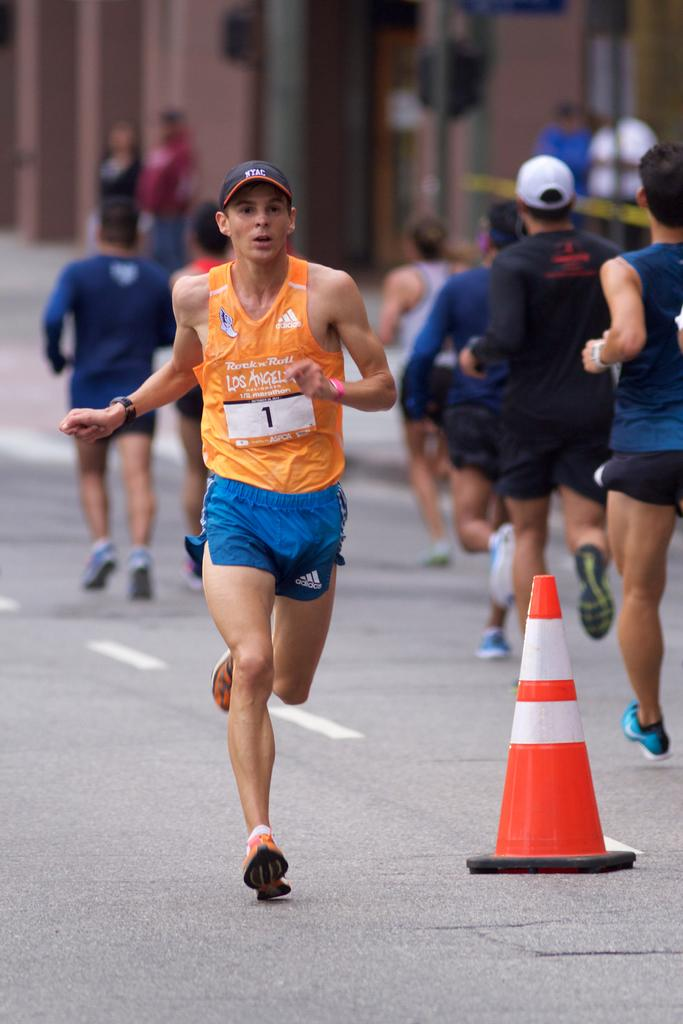What is happening in the image involving the group of people? The people in the image are running. Can you describe the person in front of the group? The person in front is wearing an orange and blue dress. What can be seen in the background of the image? There are poles and a brown-colored building in the background of the image. What type of prose is being recited by the goat in the image? There is no goat present in the image, and therefore no prose is being recited. What role does the mother play in the image? There is no mention of a mother in the image, so it is impossible to determine her role. 